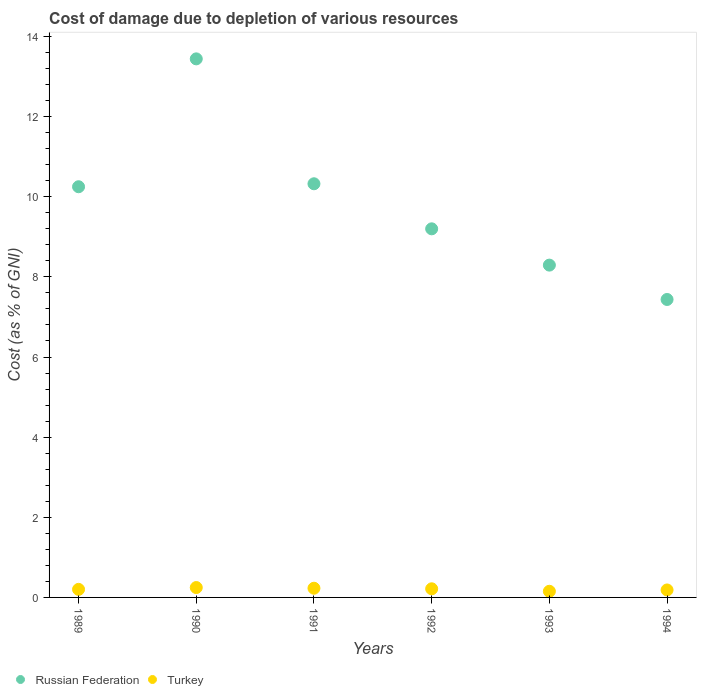What is the cost of damage caused due to the depletion of various resources in Russian Federation in 1990?
Your answer should be very brief. 13.44. Across all years, what is the maximum cost of damage caused due to the depletion of various resources in Turkey?
Your answer should be compact. 0.25. Across all years, what is the minimum cost of damage caused due to the depletion of various resources in Turkey?
Provide a short and direct response. 0.15. In which year was the cost of damage caused due to the depletion of various resources in Turkey maximum?
Ensure brevity in your answer.  1990. What is the total cost of damage caused due to the depletion of various resources in Russian Federation in the graph?
Your answer should be very brief. 58.94. What is the difference between the cost of damage caused due to the depletion of various resources in Russian Federation in 1990 and that in 1994?
Provide a short and direct response. 6.01. What is the difference between the cost of damage caused due to the depletion of various resources in Russian Federation in 1993 and the cost of damage caused due to the depletion of various resources in Turkey in 1991?
Provide a short and direct response. 8.06. What is the average cost of damage caused due to the depletion of various resources in Russian Federation per year?
Provide a succinct answer. 9.82. In the year 1994, what is the difference between the cost of damage caused due to the depletion of various resources in Turkey and cost of damage caused due to the depletion of various resources in Russian Federation?
Offer a very short reply. -7.25. What is the ratio of the cost of damage caused due to the depletion of various resources in Turkey in 1991 to that in 1992?
Offer a very short reply. 1.07. Is the cost of damage caused due to the depletion of various resources in Turkey in 1990 less than that in 1993?
Offer a terse response. No. What is the difference between the highest and the second highest cost of damage caused due to the depletion of various resources in Russian Federation?
Provide a short and direct response. 3.12. What is the difference between the highest and the lowest cost of damage caused due to the depletion of various resources in Turkey?
Offer a very short reply. 0.09. Is the sum of the cost of damage caused due to the depletion of various resources in Russian Federation in 1989 and 1990 greater than the maximum cost of damage caused due to the depletion of various resources in Turkey across all years?
Give a very brief answer. Yes. Is the cost of damage caused due to the depletion of various resources in Russian Federation strictly greater than the cost of damage caused due to the depletion of various resources in Turkey over the years?
Make the answer very short. Yes. Is the cost of damage caused due to the depletion of various resources in Russian Federation strictly less than the cost of damage caused due to the depletion of various resources in Turkey over the years?
Keep it short and to the point. No. How many years are there in the graph?
Your response must be concise. 6. Are the values on the major ticks of Y-axis written in scientific E-notation?
Provide a succinct answer. No. Does the graph contain grids?
Ensure brevity in your answer.  No. What is the title of the graph?
Offer a terse response. Cost of damage due to depletion of various resources. What is the label or title of the Y-axis?
Give a very brief answer. Cost (as % of GNI). What is the Cost (as % of GNI) in Russian Federation in 1989?
Provide a short and direct response. 10.25. What is the Cost (as % of GNI) in Turkey in 1989?
Your answer should be compact. 0.2. What is the Cost (as % of GNI) in Russian Federation in 1990?
Your response must be concise. 13.44. What is the Cost (as % of GNI) of Turkey in 1990?
Ensure brevity in your answer.  0.25. What is the Cost (as % of GNI) of Russian Federation in 1991?
Keep it short and to the point. 10.32. What is the Cost (as % of GNI) of Turkey in 1991?
Your response must be concise. 0.23. What is the Cost (as % of GNI) of Russian Federation in 1992?
Provide a succinct answer. 9.2. What is the Cost (as % of GNI) of Turkey in 1992?
Your answer should be very brief. 0.22. What is the Cost (as % of GNI) of Russian Federation in 1993?
Keep it short and to the point. 8.29. What is the Cost (as % of GNI) in Turkey in 1993?
Your answer should be compact. 0.15. What is the Cost (as % of GNI) of Russian Federation in 1994?
Keep it short and to the point. 7.44. What is the Cost (as % of GNI) in Turkey in 1994?
Ensure brevity in your answer.  0.19. Across all years, what is the maximum Cost (as % of GNI) in Russian Federation?
Your answer should be very brief. 13.44. Across all years, what is the maximum Cost (as % of GNI) of Turkey?
Your answer should be very brief. 0.25. Across all years, what is the minimum Cost (as % of GNI) in Russian Federation?
Your answer should be very brief. 7.44. Across all years, what is the minimum Cost (as % of GNI) of Turkey?
Ensure brevity in your answer.  0.15. What is the total Cost (as % of GNI) of Russian Federation in the graph?
Offer a terse response. 58.94. What is the total Cost (as % of GNI) in Turkey in the graph?
Make the answer very short. 1.23. What is the difference between the Cost (as % of GNI) in Russian Federation in 1989 and that in 1990?
Make the answer very short. -3.19. What is the difference between the Cost (as % of GNI) of Turkey in 1989 and that in 1990?
Your response must be concise. -0.05. What is the difference between the Cost (as % of GNI) of Russian Federation in 1989 and that in 1991?
Your response must be concise. -0.07. What is the difference between the Cost (as % of GNI) in Turkey in 1989 and that in 1991?
Provide a succinct answer. -0.03. What is the difference between the Cost (as % of GNI) in Russian Federation in 1989 and that in 1992?
Your response must be concise. 1.05. What is the difference between the Cost (as % of GNI) in Turkey in 1989 and that in 1992?
Your answer should be compact. -0.01. What is the difference between the Cost (as % of GNI) in Russian Federation in 1989 and that in 1993?
Offer a terse response. 1.96. What is the difference between the Cost (as % of GNI) of Turkey in 1989 and that in 1993?
Offer a very short reply. 0.05. What is the difference between the Cost (as % of GNI) in Russian Federation in 1989 and that in 1994?
Make the answer very short. 2.81. What is the difference between the Cost (as % of GNI) of Turkey in 1989 and that in 1994?
Give a very brief answer. 0.01. What is the difference between the Cost (as % of GNI) of Russian Federation in 1990 and that in 1991?
Your response must be concise. 3.12. What is the difference between the Cost (as % of GNI) of Turkey in 1990 and that in 1991?
Provide a succinct answer. 0.02. What is the difference between the Cost (as % of GNI) of Russian Federation in 1990 and that in 1992?
Offer a terse response. 4.24. What is the difference between the Cost (as % of GNI) of Turkey in 1990 and that in 1992?
Ensure brevity in your answer.  0.03. What is the difference between the Cost (as % of GNI) of Russian Federation in 1990 and that in 1993?
Make the answer very short. 5.15. What is the difference between the Cost (as % of GNI) of Turkey in 1990 and that in 1993?
Offer a very short reply. 0.09. What is the difference between the Cost (as % of GNI) in Russian Federation in 1990 and that in 1994?
Offer a terse response. 6.01. What is the difference between the Cost (as % of GNI) of Turkey in 1990 and that in 1994?
Offer a terse response. 0.06. What is the difference between the Cost (as % of GNI) in Russian Federation in 1991 and that in 1992?
Offer a very short reply. 1.12. What is the difference between the Cost (as % of GNI) in Turkey in 1991 and that in 1992?
Provide a short and direct response. 0.01. What is the difference between the Cost (as % of GNI) of Russian Federation in 1991 and that in 1993?
Provide a succinct answer. 2.03. What is the difference between the Cost (as % of GNI) of Turkey in 1991 and that in 1993?
Provide a short and direct response. 0.08. What is the difference between the Cost (as % of GNI) of Russian Federation in 1991 and that in 1994?
Provide a short and direct response. 2.89. What is the difference between the Cost (as % of GNI) in Turkey in 1991 and that in 1994?
Offer a very short reply. 0.04. What is the difference between the Cost (as % of GNI) of Russian Federation in 1992 and that in 1993?
Make the answer very short. 0.91. What is the difference between the Cost (as % of GNI) in Turkey in 1992 and that in 1993?
Ensure brevity in your answer.  0.06. What is the difference between the Cost (as % of GNI) in Russian Federation in 1992 and that in 1994?
Offer a very short reply. 1.76. What is the difference between the Cost (as % of GNI) of Turkey in 1992 and that in 1994?
Provide a short and direct response. 0.03. What is the difference between the Cost (as % of GNI) of Russian Federation in 1993 and that in 1994?
Make the answer very short. 0.86. What is the difference between the Cost (as % of GNI) in Turkey in 1993 and that in 1994?
Provide a succinct answer. -0.03. What is the difference between the Cost (as % of GNI) in Russian Federation in 1989 and the Cost (as % of GNI) in Turkey in 1990?
Offer a very short reply. 10. What is the difference between the Cost (as % of GNI) in Russian Federation in 1989 and the Cost (as % of GNI) in Turkey in 1991?
Ensure brevity in your answer.  10.02. What is the difference between the Cost (as % of GNI) of Russian Federation in 1989 and the Cost (as % of GNI) of Turkey in 1992?
Your answer should be compact. 10.03. What is the difference between the Cost (as % of GNI) of Russian Federation in 1989 and the Cost (as % of GNI) of Turkey in 1993?
Your answer should be very brief. 10.1. What is the difference between the Cost (as % of GNI) of Russian Federation in 1989 and the Cost (as % of GNI) of Turkey in 1994?
Give a very brief answer. 10.06. What is the difference between the Cost (as % of GNI) in Russian Federation in 1990 and the Cost (as % of GNI) in Turkey in 1991?
Your response must be concise. 13.21. What is the difference between the Cost (as % of GNI) in Russian Federation in 1990 and the Cost (as % of GNI) in Turkey in 1992?
Make the answer very short. 13.23. What is the difference between the Cost (as % of GNI) in Russian Federation in 1990 and the Cost (as % of GNI) in Turkey in 1993?
Provide a short and direct response. 13.29. What is the difference between the Cost (as % of GNI) of Russian Federation in 1990 and the Cost (as % of GNI) of Turkey in 1994?
Your response must be concise. 13.26. What is the difference between the Cost (as % of GNI) in Russian Federation in 1991 and the Cost (as % of GNI) in Turkey in 1992?
Your answer should be very brief. 10.11. What is the difference between the Cost (as % of GNI) in Russian Federation in 1991 and the Cost (as % of GNI) in Turkey in 1993?
Provide a short and direct response. 10.17. What is the difference between the Cost (as % of GNI) of Russian Federation in 1991 and the Cost (as % of GNI) of Turkey in 1994?
Ensure brevity in your answer.  10.14. What is the difference between the Cost (as % of GNI) in Russian Federation in 1992 and the Cost (as % of GNI) in Turkey in 1993?
Make the answer very short. 9.05. What is the difference between the Cost (as % of GNI) in Russian Federation in 1992 and the Cost (as % of GNI) in Turkey in 1994?
Your answer should be compact. 9.01. What is the difference between the Cost (as % of GNI) of Russian Federation in 1993 and the Cost (as % of GNI) of Turkey in 1994?
Your answer should be compact. 8.11. What is the average Cost (as % of GNI) of Russian Federation per year?
Give a very brief answer. 9.82. What is the average Cost (as % of GNI) in Turkey per year?
Your answer should be compact. 0.21. In the year 1989, what is the difference between the Cost (as % of GNI) in Russian Federation and Cost (as % of GNI) in Turkey?
Keep it short and to the point. 10.05. In the year 1990, what is the difference between the Cost (as % of GNI) in Russian Federation and Cost (as % of GNI) in Turkey?
Ensure brevity in your answer.  13.19. In the year 1991, what is the difference between the Cost (as % of GNI) in Russian Federation and Cost (as % of GNI) in Turkey?
Your answer should be very brief. 10.09. In the year 1992, what is the difference between the Cost (as % of GNI) of Russian Federation and Cost (as % of GNI) of Turkey?
Ensure brevity in your answer.  8.98. In the year 1993, what is the difference between the Cost (as % of GNI) in Russian Federation and Cost (as % of GNI) in Turkey?
Give a very brief answer. 8.14. In the year 1994, what is the difference between the Cost (as % of GNI) in Russian Federation and Cost (as % of GNI) in Turkey?
Ensure brevity in your answer.  7.25. What is the ratio of the Cost (as % of GNI) in Russian Federation in 1989 to that in 1990?
Keep it short and to the point. 0.76. What is the ratio of the Cost (as % of GNI) in Turkey in 1989 to that in 1990?
Provide a succinct answer. 0.82. What is the ratio of the Cost (as % of GNI) of Turkey in 1989 to that in 1991?
Offer a very short reply. 0.88. What is the ratio of the Cost (as % of GNI) in Russian Federation in 1989 to that in 1992?
Keep it short and to the point. 1.11. What is the ratio of the Cost (as % of GNI) of Turkey in 1989 to that in 1992?
Your answer should be very brief. 0.93. What is the ratio of the Cost (as % of GNI) of Russian Federation in 1989 to that in 1993?
Your answer should be very brief. 1.24. What is the ratio of the Cost (as % of GNI) in Turkey in 1989 to that in 1993?
Ensure brevity in your answer.  1.31. What is the ratio of the Cost (as % of GNI) in Russian Federation in 1989 to that in 1994?
Provide a short and direct response. 1.38. What is the ratio of the Cost (as % of GNI) of Turkey in 1989 to that in 1994?
Offer a terse response. 1.08. What is the ratio of the Cost (as % of GNI) in Russian Federation in 1990 to that in 1991?
Provide a succinct answer. 1.3. What is the ratio of the Cost (as % of GNI) of Turkey in 1990 to that in 1991?
Your answer should be compact. 1.07. What is the ratio of the Cost (as % of GNI) in Russian Federation in 1990 to that in 1992?
Offer a terse response. 1.46. What is the ratio of the Cost (as % of GNI) of Turkey in 1990 to that in 1992?
Give a very brief answer. 1.15. What is the ratio of the Cost (as % of GNI) of Russian Federation in 1990 to that in 1993?
Your response must be concise. 1.62. What is the ratio of the Cost (as % of GNI) of Turkey in 1990 to that in 1993?
Give a very brief answer. 1.61. What is the ratio of the Cost (as % of GNI) of Russian Federation in 1990 to that in 1994?
Provide a succinct answer. 1.81. What is the ratio of the Cost (as % of GNI) in Turkey in 1990 to that in 1994?
Your answer should be very brief. 1.32. What is the ratio of the Cost (as % of GNI) in Russian Federation in 1991 to that in 1992?
Give a very brief answer. 1.12. What is the ratio of the Cost (as % of GNI) in Turkey in 1991 to that in 1992?
Give a very brief answer. 1.07. What is the ratio of the Cost (as % of GNI) in Russian Federation in 1991 to that in 1993?
Give a very brief answer. 1.24. What is the ratio of the Cost (as % of GNI) of Turkey in 1991 to that in 1993?
Offer a very short reply. 1.5. What is the ratio of the Cost (as % of GNI) of Russian Federation in 1991 to that in 1994?
Your answer should be compact. 1.39. What is the ratio of the Cost (as % of GNI) of Turkey in 1991 to that in 1994?
Make the answer very short. 1.23. What is the ratio of the Cost (as % of GNI) of Russian Federation in 1992 to that in 1993?
Your answer should be very brief. 1.11. What is the ratio of the Cost (as % of GNI) of Turkey in 1992 to that in 1993?
Keep it short and to the point. 1.4. What is the ratio of the Cost (as % of GNI) in Russian Federation in 1992 to that in 1994?
Provide a short and direct response. 1.24. What is the ratio of the Cost (as % of GNI) in Turkey in 1992 to that in 1994?
Your answer should be very brief. 1.15. What is the ratio of the Cost (as % of GNI) of Russian Federation in 1993 to that in 1994?
Ensure brevity in your answer.  1.12. What is the ratio of the Cost (as % of GNI) in Turkey in 1993 to that in 1994?
Make the answer very short. 0.82. What is the difference between the highest and the second highest Cost (as % of GNI) of Russian Federation?
Provide a short and direct response. 3.12. What is the difference between the highest and the second highest Cost (as % of GNI) in Turkey?
Keep it short and to the point. 0.02. What is the difference between the highest and the lowest Cost (as % of GNI) of Russian Federation?
Ensure brevity in your answer.  6.01. What is the difference between the highest and the lowest Cost (as % of GNI) in Turkey?
Your answer should be very brief. 0.09. 